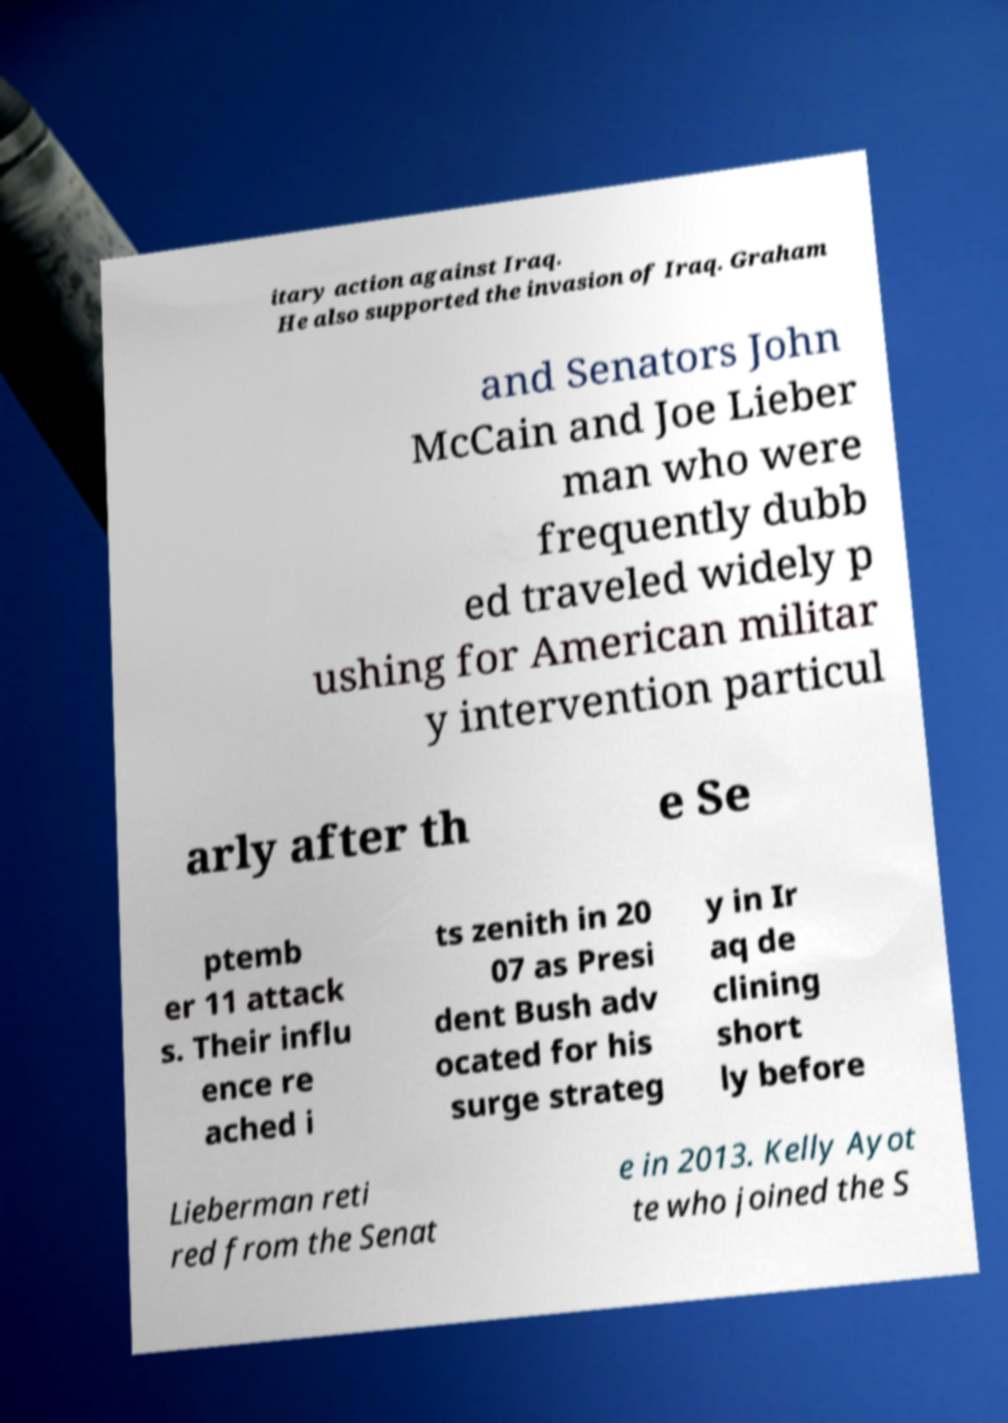Please read and relay the text visible in this image. What does it say? itary action against Iraq. He also supported the invasion of Iraq. Graham and Senators John McCain and Joe Lieber man who were frequently dubb ed traveled widely p ushing for American militar y intervention particul arly after th e Se ptemb er 11 attack s. Their influ ence re ached i ts zenith in 20 07 as Presi dent Bush adv ocated for his surge strateg y in Ir aq de clining short ly before Lieberman reti red from the Senat e in 2013. Kelly Ayot te who joined the S 